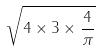<formula> <loc_0><loc_0><loc_500><loc_500>\sqrt { 4 \times 3 \times \frac { 4 } { \pi } }</formula> 